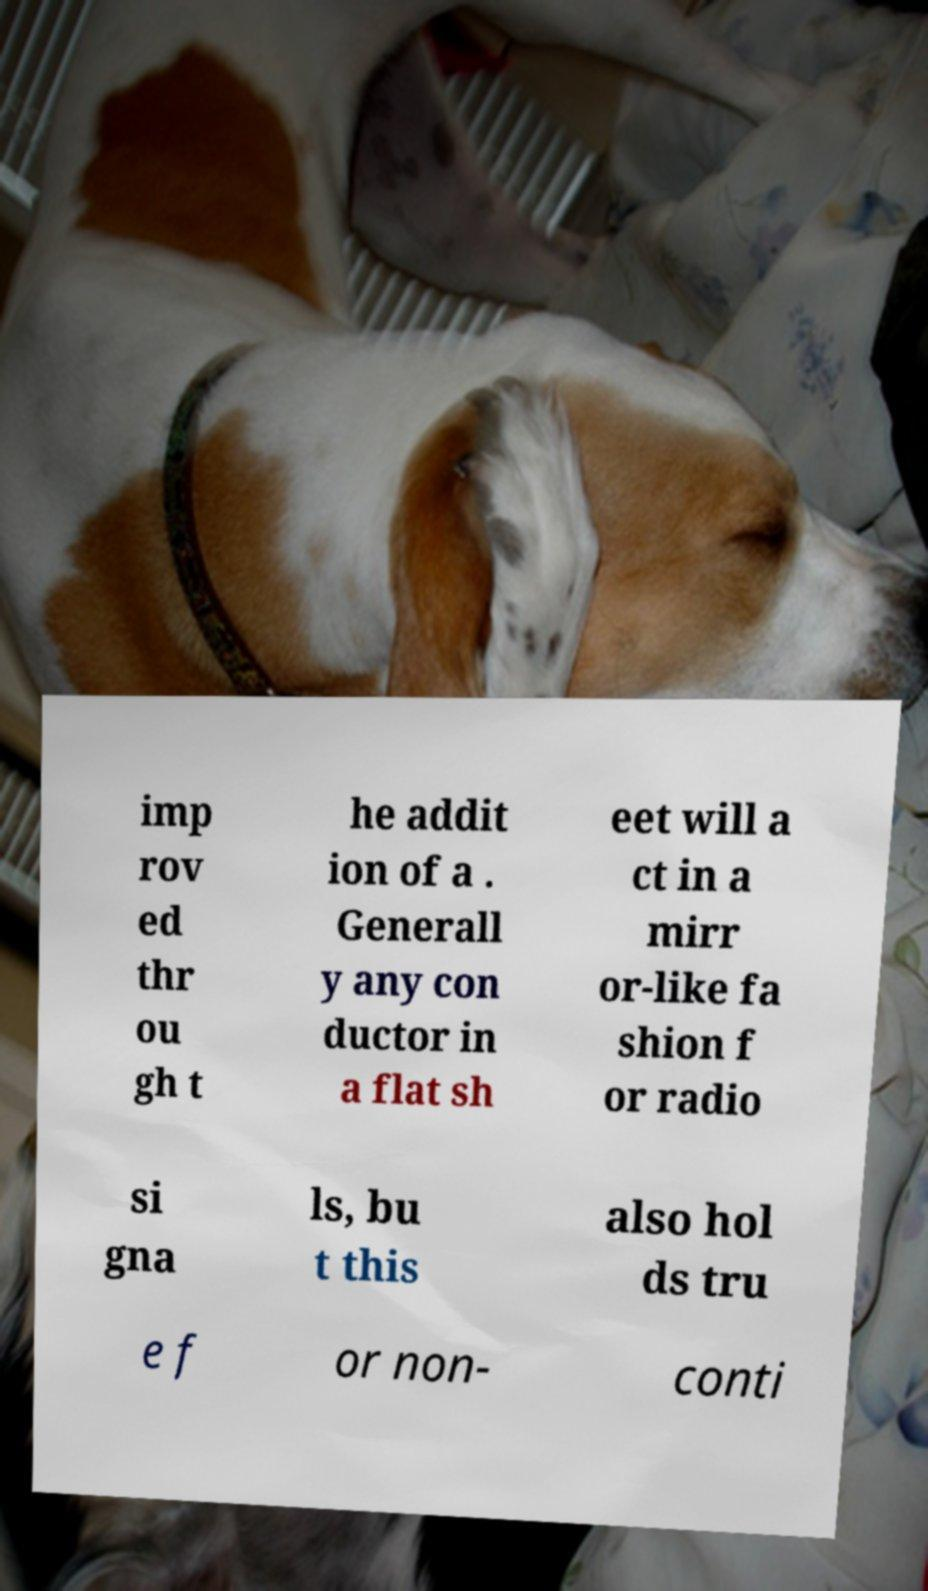For documentation purposes, I need the text within this image transcribed. Could you provide that? imp rov ed thr ou gh t he addit ion of a . Generall y any con ductor in a flat sh eet will a ct in a mirr or-like fa shion f or radio si gna ls, bu t this also hol ds tru e f or non- conti 